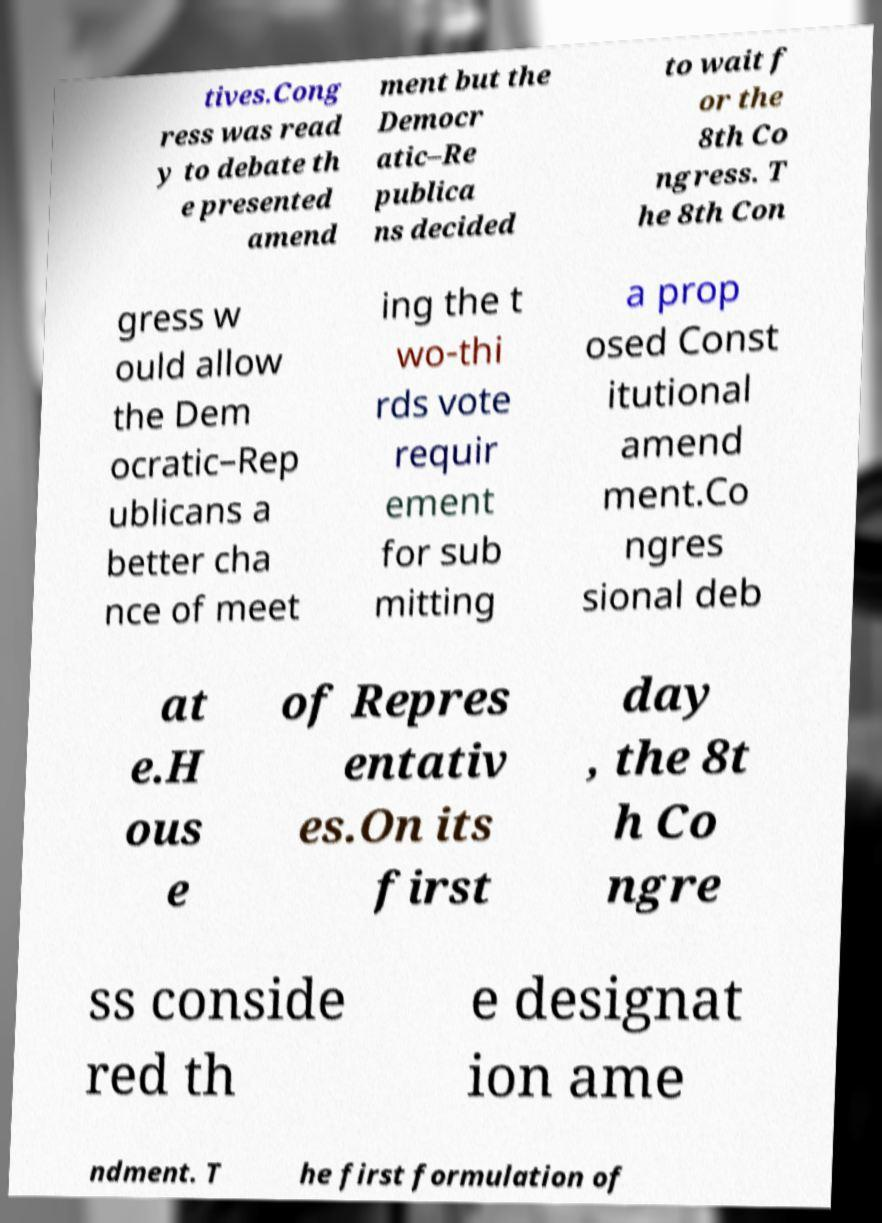What messages or text are displayed in this image? I need them in a readable, typed format. tives.Cong ress was read y to debate th e presented amend ment but the Democr atic–Re publica ns decided to wait f or the 8th Co ngress. T he 8th Con gress w ould allow the Dem ocratic–Rep ublicans a better cha nce of meet ing the t wo-thi rds vote requir ement for sub mitting a prop osed Const itutional amend ment.Co ngres sional deb at e.H ous e of Repres entativ es.On its first day , the 8t h Co ngre ss conside red th e designat ion ame ndment. T he first formulation of 